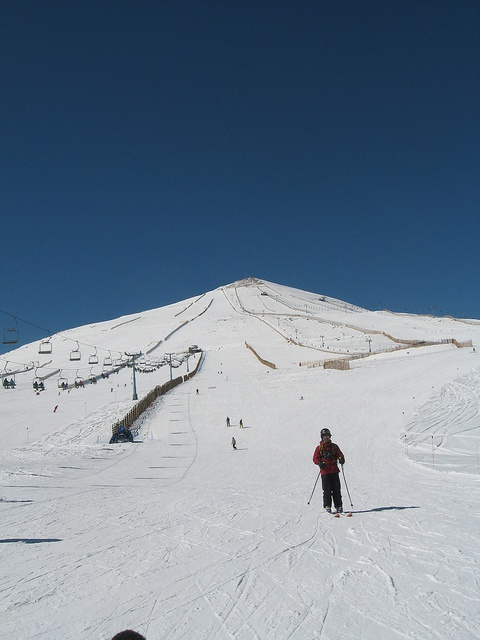Describe the objects in this image and their specific colors. I can see people in navy, black, maroon, gray, and darkgray tones, skis in navy, gray, darkgray, and lightgray tones, people in navy, gray, darkgray, black, and lightgray tones, people in navy, gray, darkgray, black, and darkgreen tones, and people in navy, black, gray, and purple tones in this image. 